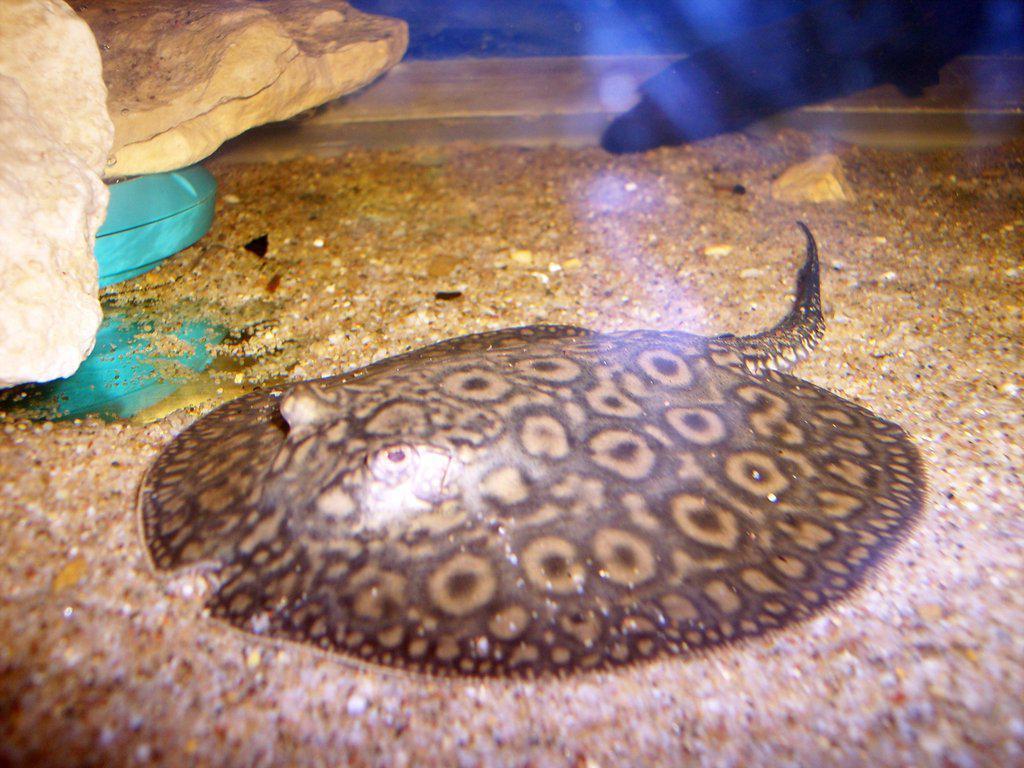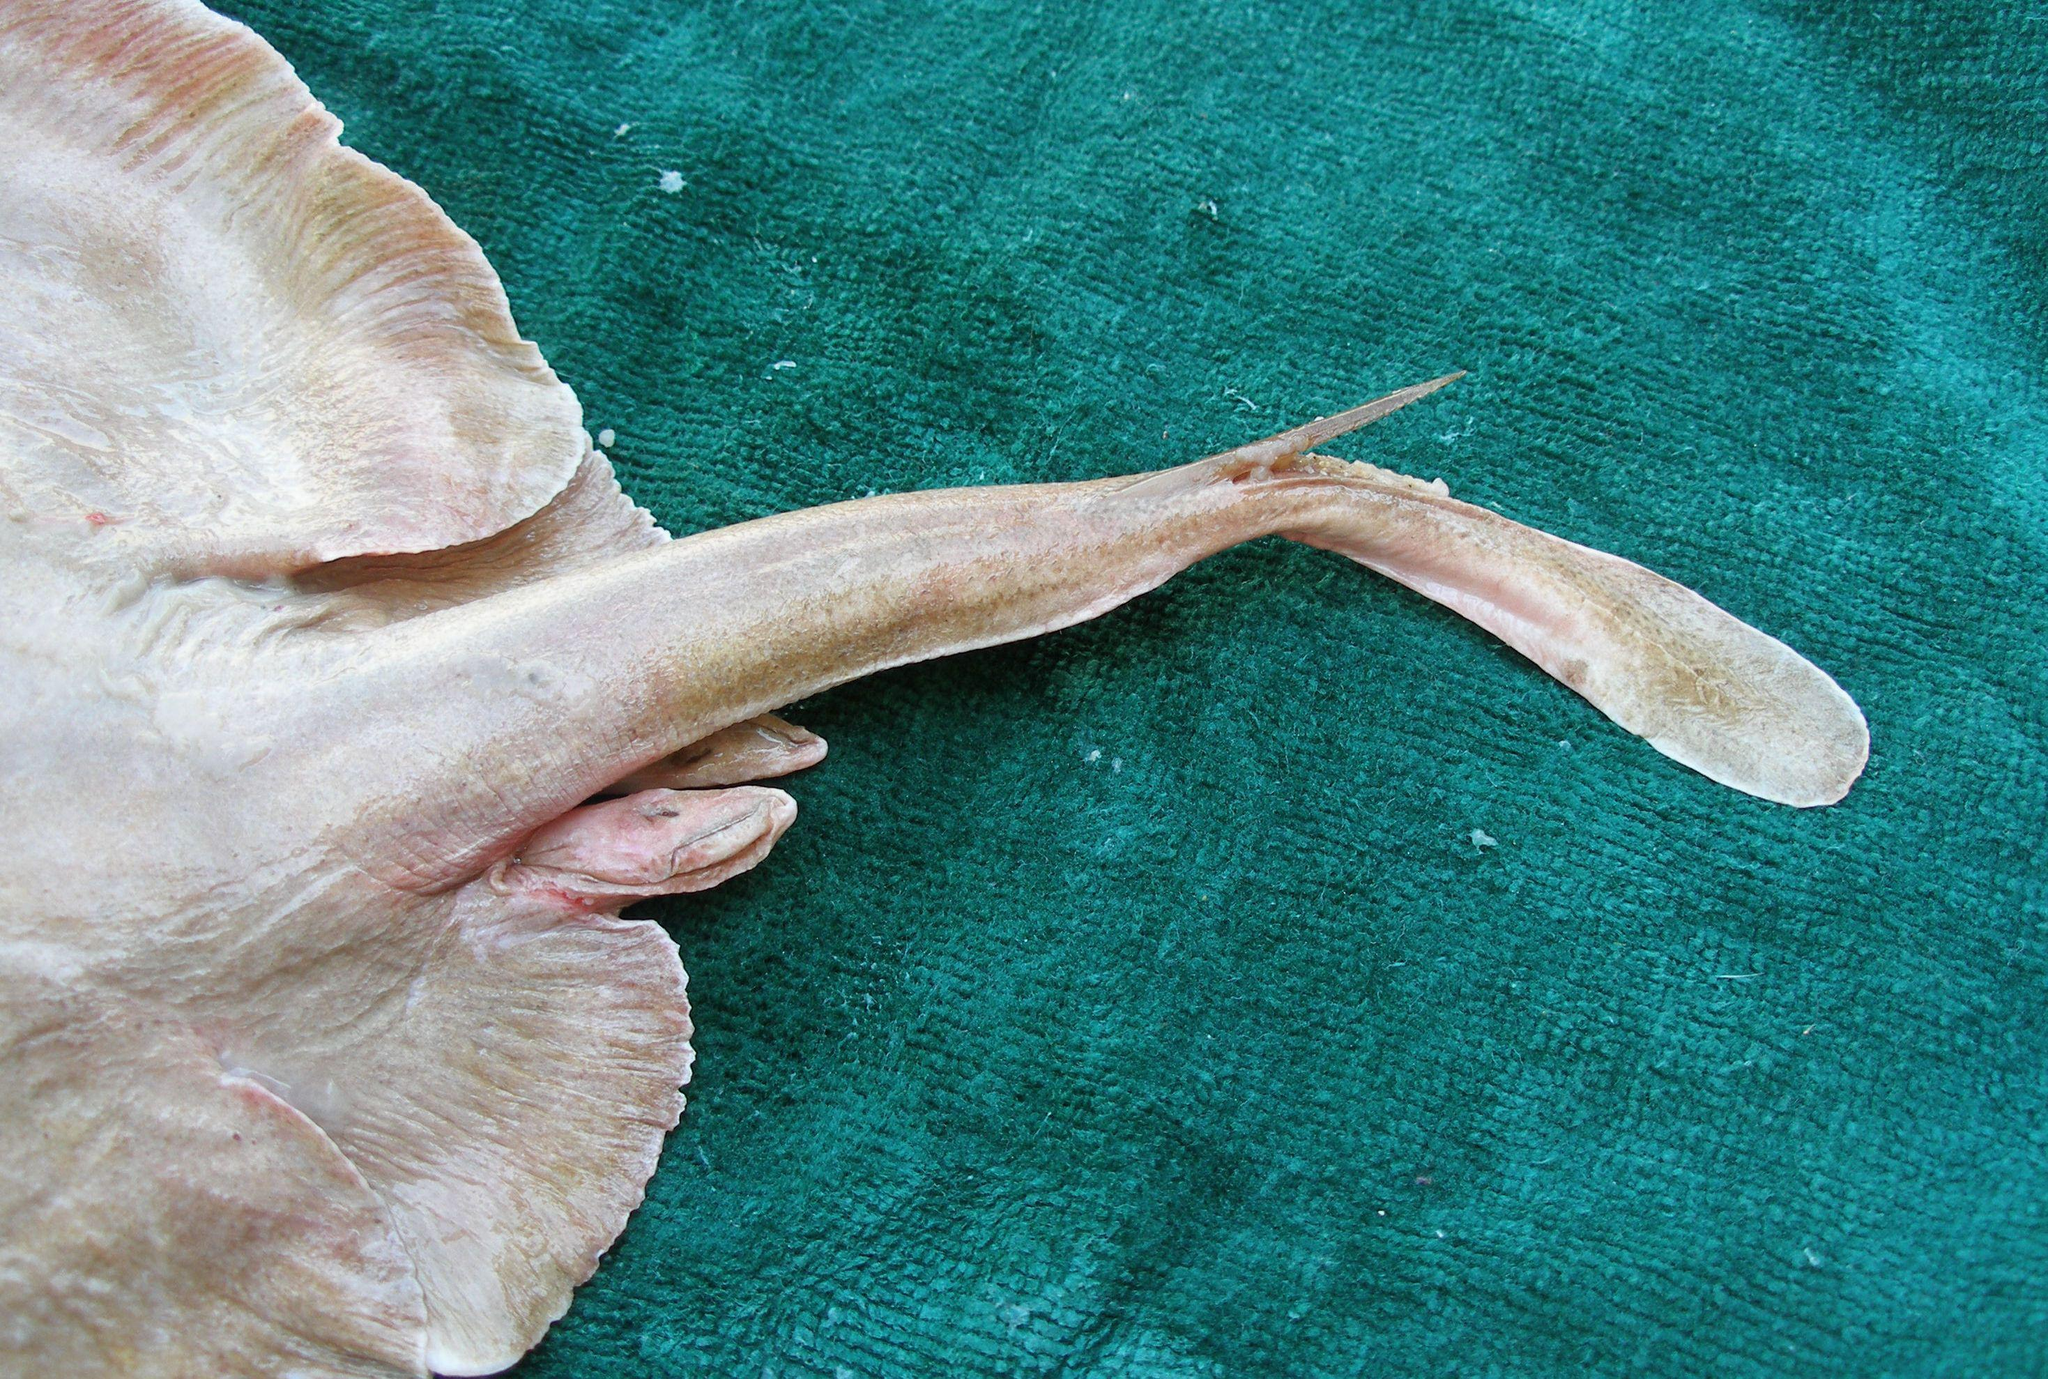The first image is the image on the left, the second image is the image on the right. Assess this claim about the two images: "All stingrays shown have distinctive colorful dot patterns.". Correct or not? Answer yes or no. No. 